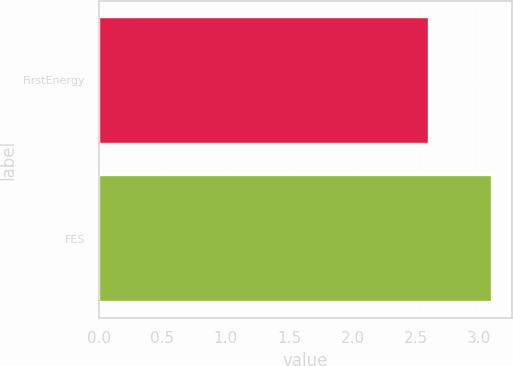Convert chart. <chart><loc_0><loc_0><loc_500><loc_500><bar_chart><fcel>FirstEnergy<fcel>FES<nl><fcel>2.6<fcel>3.1<nl></chart> 